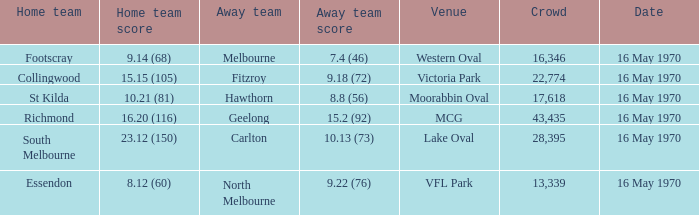What's the place for the home team that achieved Western Oval. 